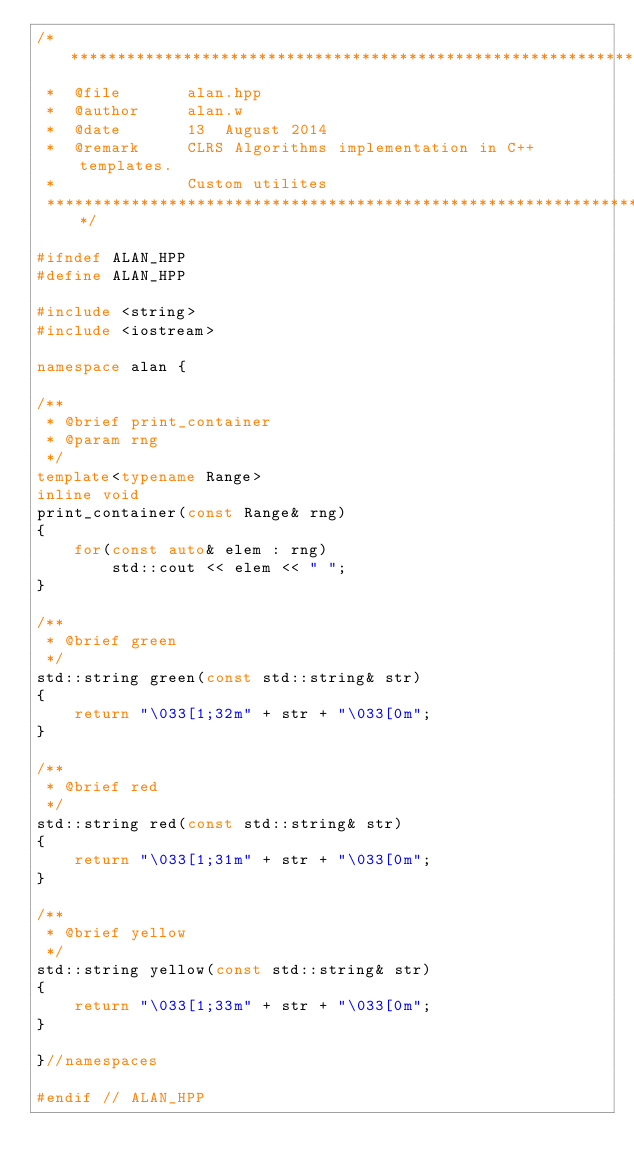<code> <loc_0><loc_0><loc_500><loc_500><_C++_>/***************************************************************************
 *  @file       alan.hpp
 *  @author     alan.w
 *  @date       13  August 2014
 *  @remark     CLRS Algorithms implementation in C++ templates.
 *              Custom utilites
 ***************************************************************************/

#ifndef ALAN_HPP
#define ALAN_HPP

#include <string>
#include <iostream>

namespace alan {

/**
 * @brief print_container
 * @param rng
 */
template<typename Range>
inline void
print_container(const Range& rng)
{
    for(const auto& elem : rng)
        std::cout << elem << " ";
}

/**
 * @brief green
 */
std::string green(const std::string& str)
{
    return "\033[1;32m" + str + "\033[0m";
}

/**
 * @brief red
 */
std::string red(const std::string& str)
{
    return "\033[1;31m" + str + "\033[0m";
}

/**
 * @brief yellow
 */
std::string yellow(const std::string& str)
{
    return "\033[1;33m" + str + "\033[0m";
}

}//namespaces

#endif // ALAN_HPP
</code> 